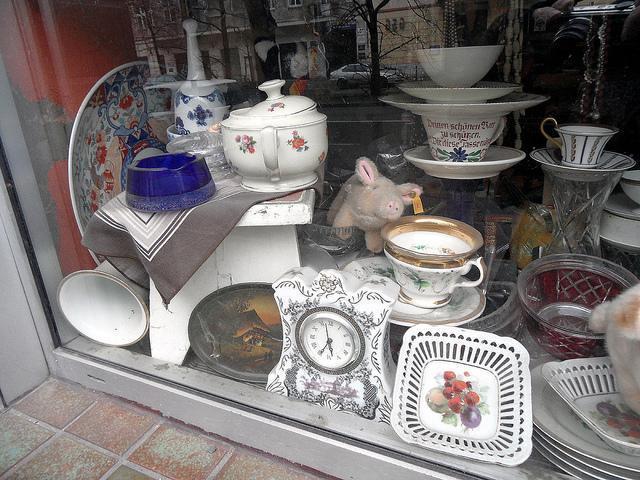How many bowls can you see?
Give a very brief answer. 6. How many cups are there?
Give a very brief answer. 3. 